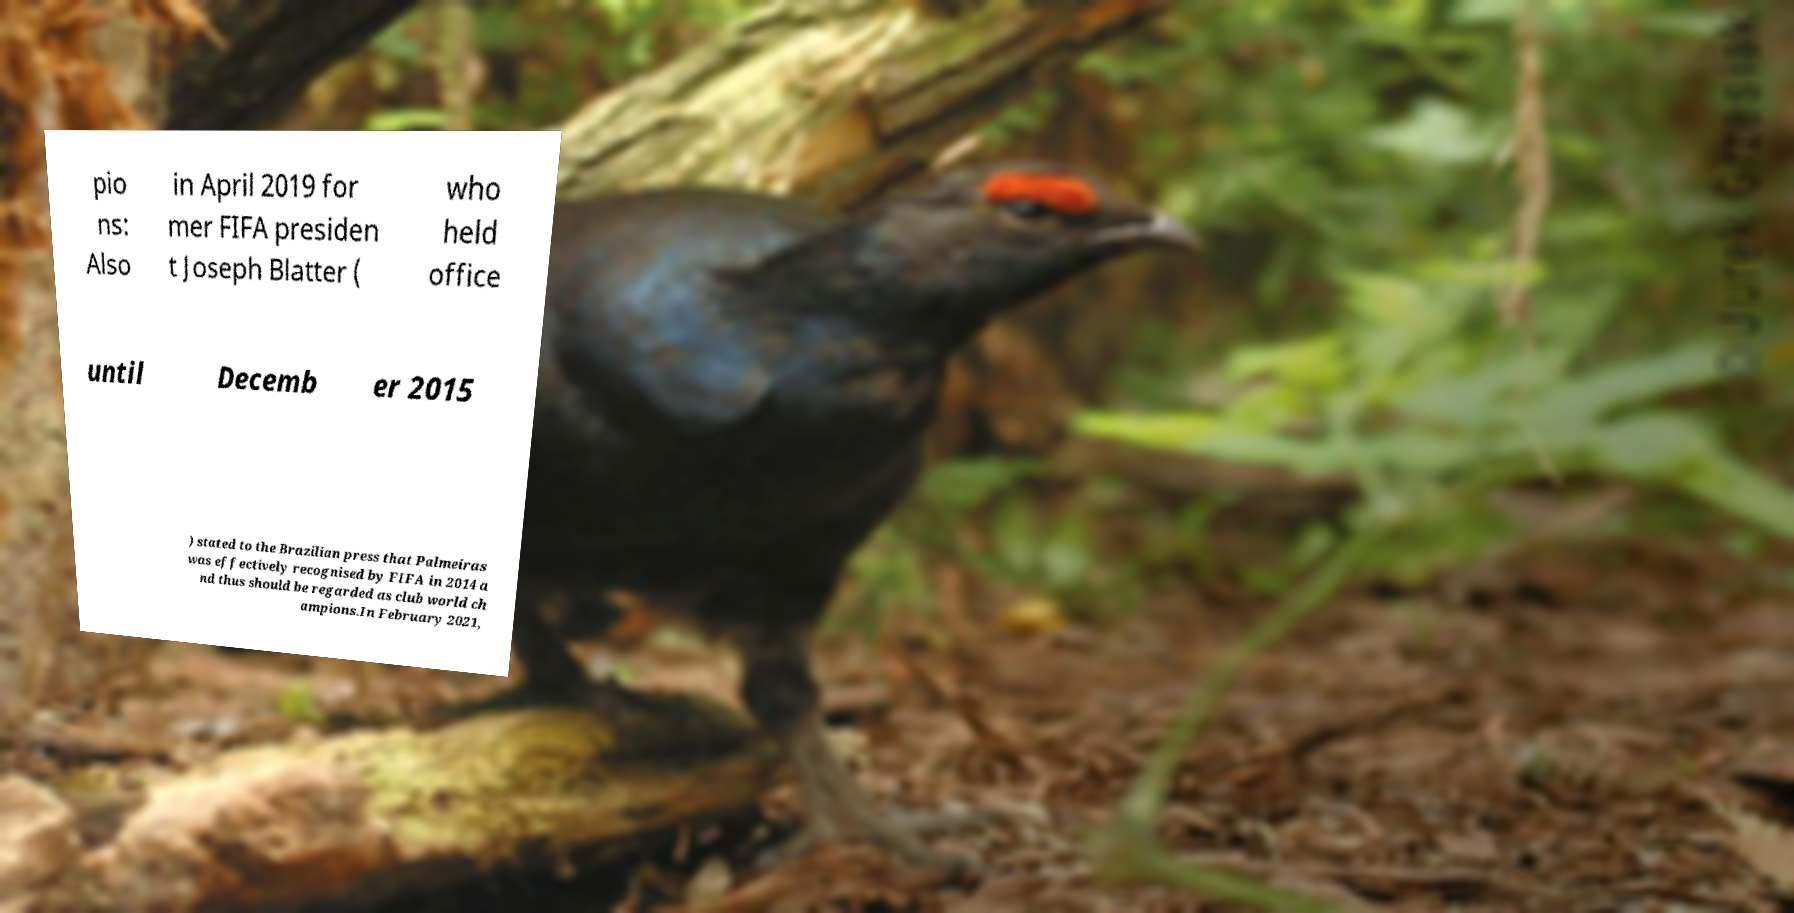I need the written content from this picture converted into text. Can you do that? pio ns: Also in April 2019 for mer FIFA presiden t Joseph Blatter ( who held office until Decemb er 2015 ) stated to the Brazilian press that Palmeiras was effectively recognised by FIFA in 2014 a nd thus should be regarded as club world ch ampions.In February 2021, 